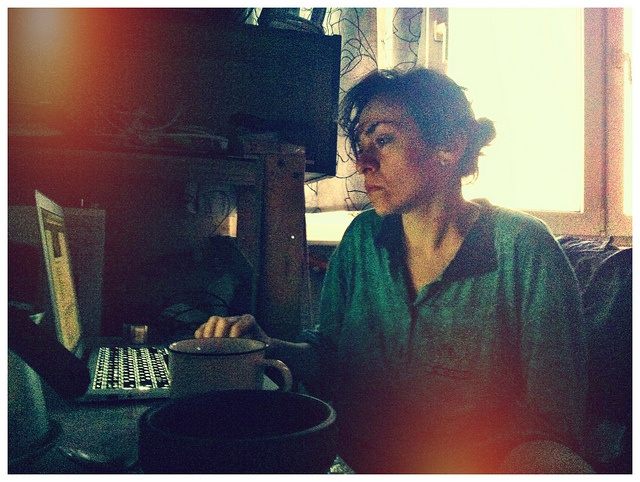Describe the objects in this image and their specific colors. I can see people in white, black, maroon, gray, and teal tones, bowl in white, black, darkblue, purple, and gray tones, laptop in white, black, olive, gray, and teal tones, and cup in white, black, gray, darkblue, and purple tones in this image. 